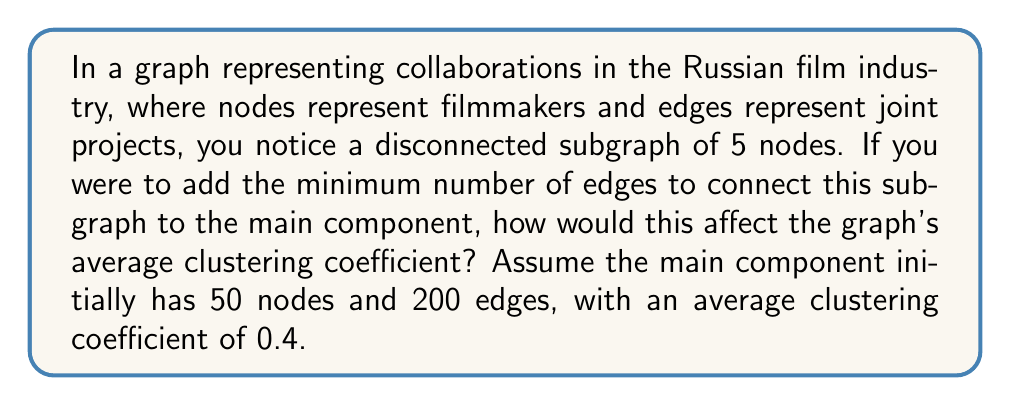Could you help me with this problem? To solve this problem, we need to understand how the addition of new edges affects the graph's structure and its average clustering coefficient. Let's break it down step-by-step:

1) First, let's recall the formula for the average clustering coefficient:

   $$ C = \frac{1}{n} \sum_{i=1}^n C_i $$

   where $n$ is the number of nodes and $C_i$ is the local clustering coefficient of node $i$.

2) The minimum number of edges to connect a subgraph of 5 nodes to the main component is 1. This new edge will create a bridge between the two components.

3) After adding this edge, we have a new graph with 55 nodes and 201 edges.

4) The addition of this single edge will not create any new triangles in the graph. It will only increase the number of possible triangles for the two nodes it connects.

5) For the node in the main component that receives the new edge, its local clustering coefficient will decrease slightly because it now has one more neighbor but no new triangles.

6) For the node in the formerly disconnected subgraph that receives the new edge, its local clustering coefficient will remain 0 (assuming it had no connections within its subgraph) or decrease (if it had connections within its subgraph).

7) The local clustering coefficients of all other nodes remain unchanged.

8) Given that only one or two nodes out of 55 have their clustering coefficients slightly decreased, and these decreases are minimal, the overall change in the average clustering coefficient will be very small.

9) We can approximate the new average clustering coefficient as:

   $$ C_{new} \approx \frac{50 \cdot 0.4 + 5 \cdot 0}{55} \approx 0.3636 $$

   This assumes the 5 nodes from the disconnected subgraph have clustering coefficients of 0, which is a simplification but gives us a lower bound.

10) The actual value will be slightly higher than this, but still lower than the original 0.4.
Answer: The addition of the minimum number of edges to connect the disconnected subgraph will cause a small decrease in the graph's average clustering coefficient, from 0.4 to approximately 0.3636, with the actual value being slightly higher but still below 0.4. 